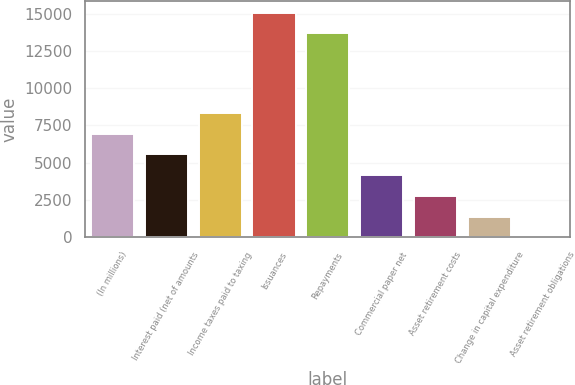Convert chart. <chart><loc_0><loc_0><loc_500><loc_500><bar_chart><fcel>(In millions)<fcel>Interest paid (net of amounts<fcel>Income taxes paid to taxing<fcel>Issuances<fcel>Repayments<fcel>Commercial paper net<fcel>Asset retirement costs<fcel>Change in capital expenditure<fcel>Asset retirement obligations<nl><fcel>6944<fcel>5556.8<fcel>8331.2<fcel>15067.2<fcel>13680<fcel>4169.6<fcel>2782.4<fcel>1395.2<fcel>8<nl></chart> 